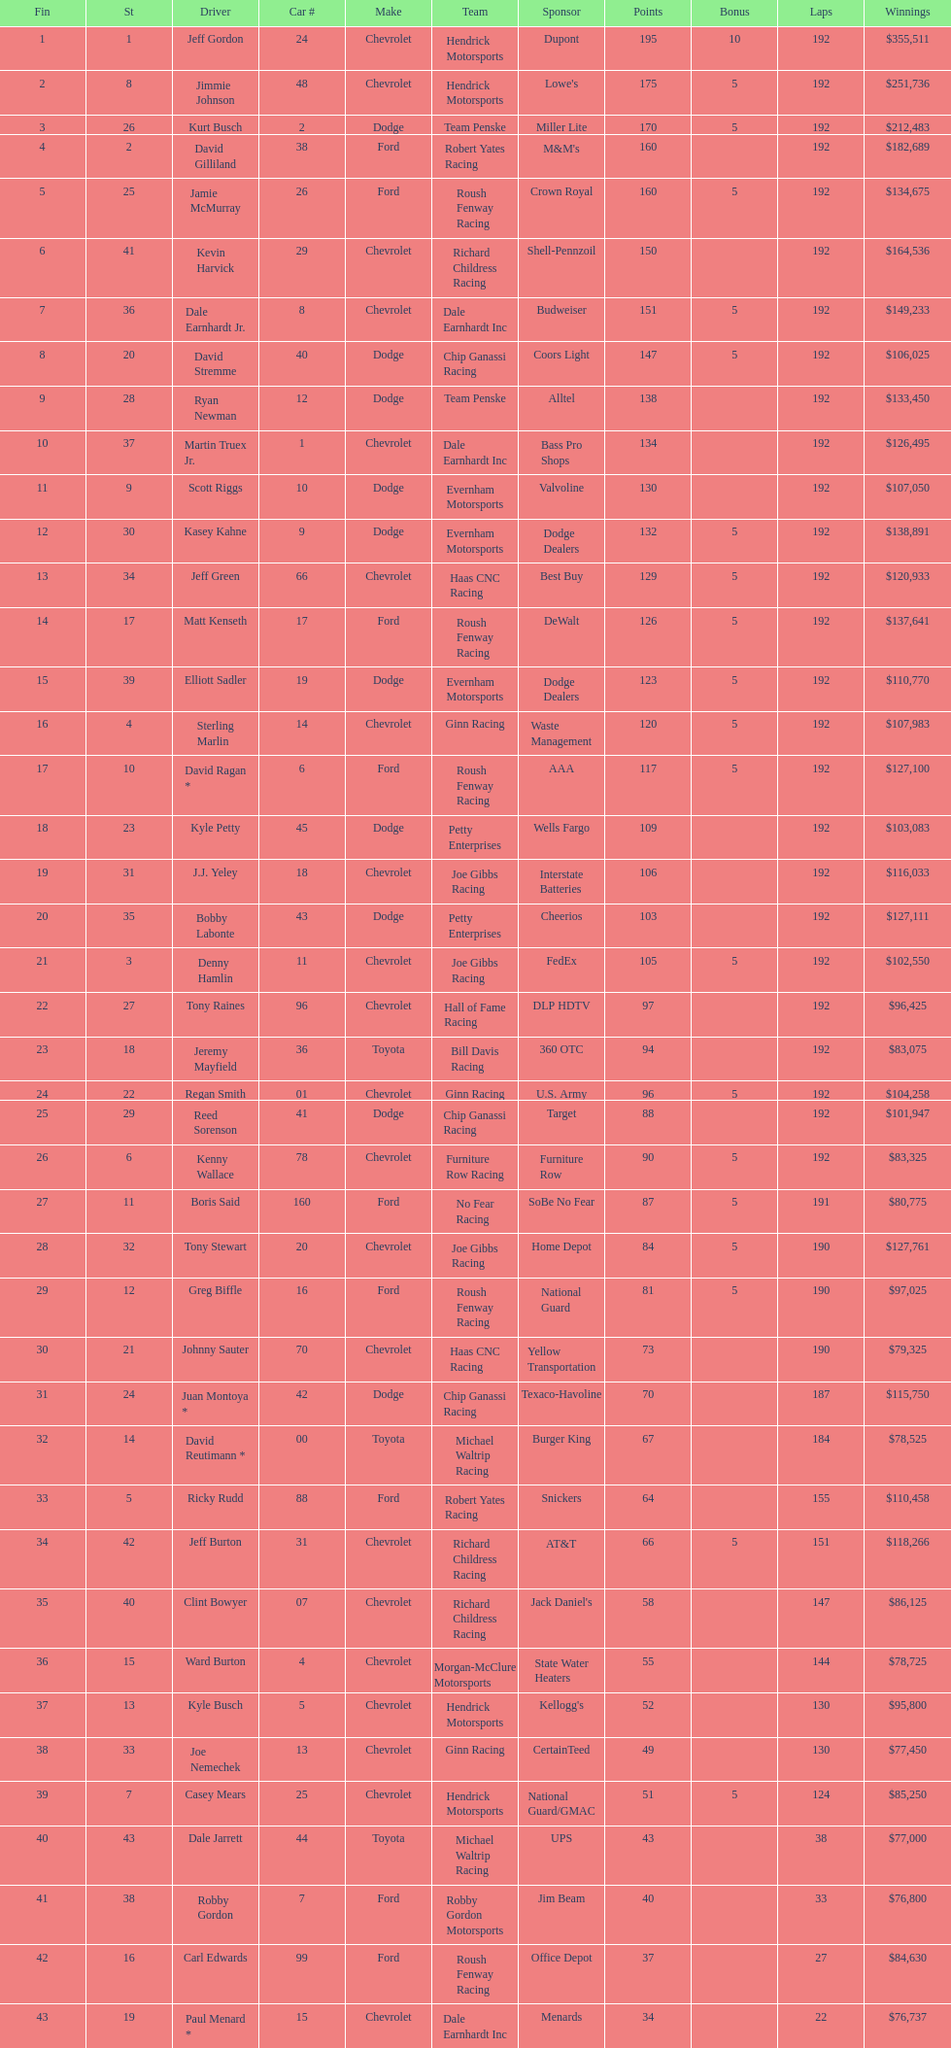Who got the most bonus points? Jeff Gordon. 